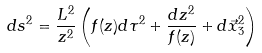Convert formula to latex. <formula><loc_0><loc_0><loc_500><loc_500>d s ^ { 2 } = \frac { L ^ { 2 } } { z ^ { 2 } } \left ( f ( z ) d \tau ^ { 2 } + \frac { d z ^ { 2 } } { f ( z ) } + d \vec { x } ^ { 2 } _ { 3 } \right )</formula> 